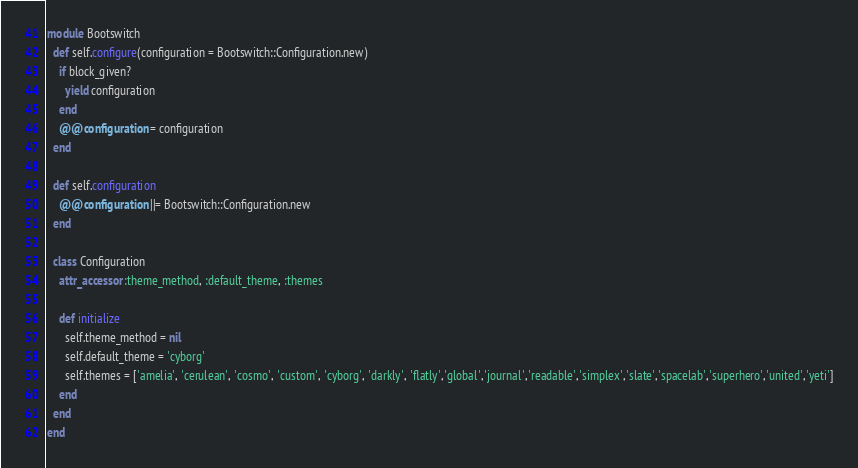Convert code to text. <code><loc_0><loc_0><loc_500><loc_500><_Ruby_>module Bootswitch
  def self.configure(configuration = Bootswitch::Configuration.new)
    if block_given?
      yield configuration
    end
    @@configuration = configuration
  end
  
  def self.configuration
    @@configuration ||= Bootswitch::Configuration.new
  end
  
  class Configuration
    attr_accessor :theme_method, :default_theme, :themes
    
    def initialize
      self.theme_method = nil
      self.default_theme = 'cyborg'
      self.themes = ['amelia', 'cerulean', 'cosmo', 'custom', 'cyborg', 'darkly', 'flatly','global','journal','readable','simplex','slate','spacelab','superhero','united','yeti']
    end
  end
end</code> 